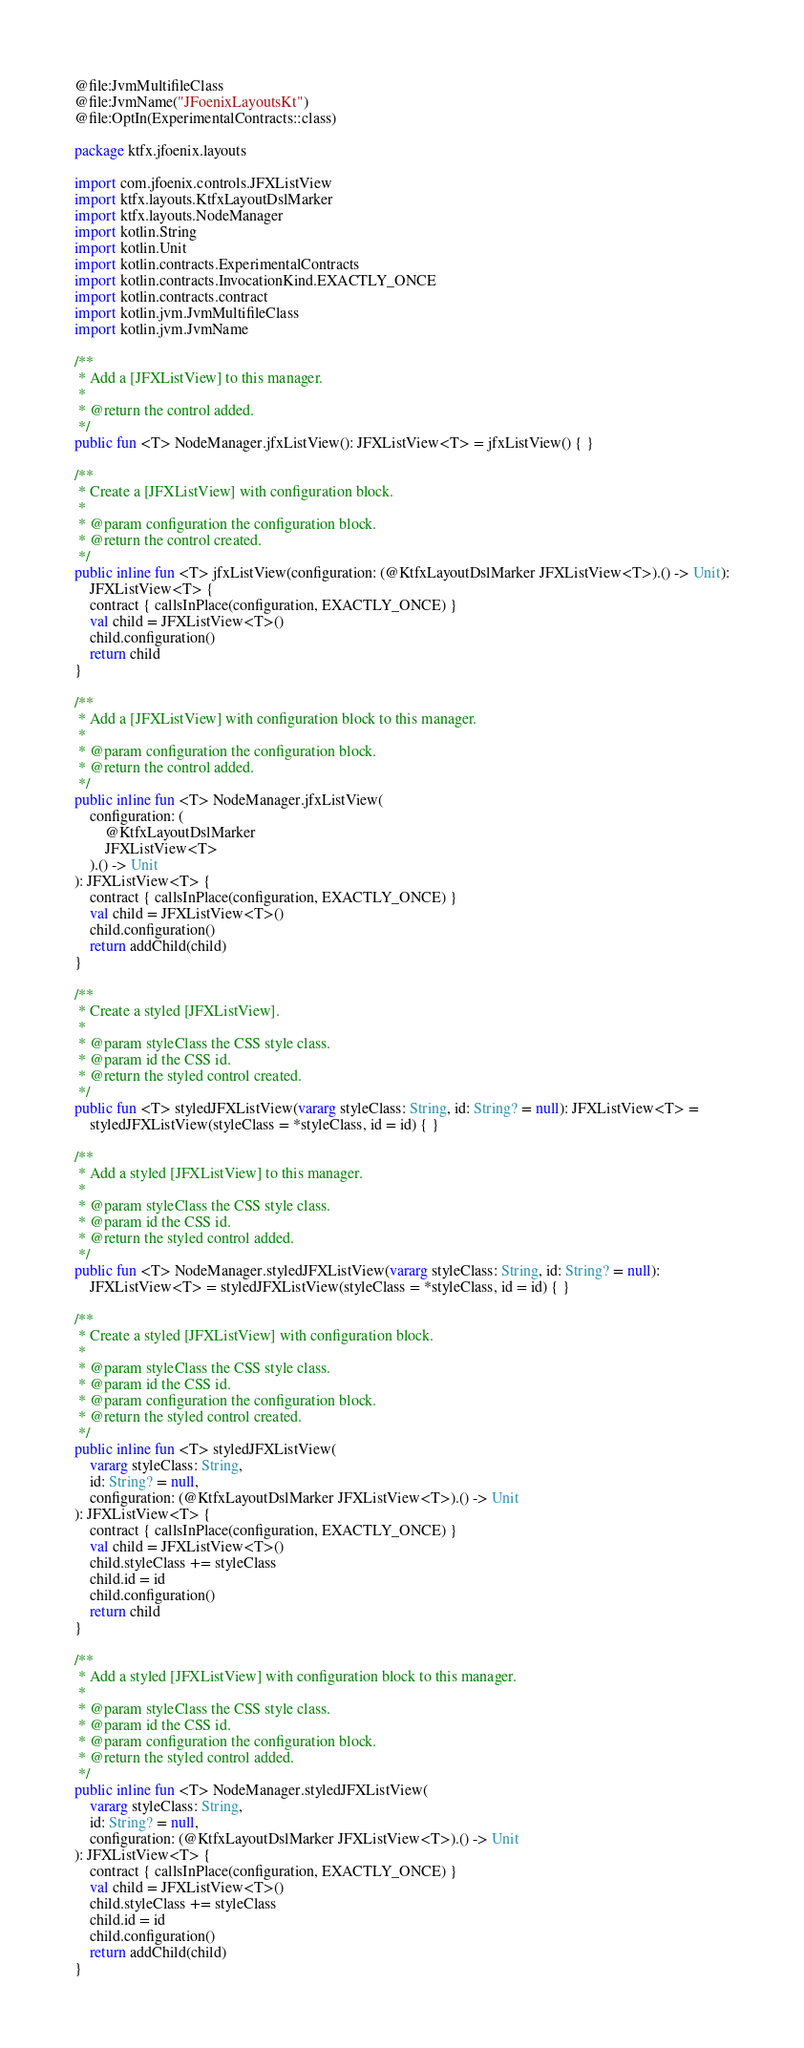Convert code to text. <code><loc_0><loc_0><loc_500><loc_500><_Kotlin_>@file:JvmMultifileClass
@file:JvmName("JFoenixLayoutsKt")
@file:OptIn(ExperimentalContracts::class)

package ktfx.jfoenix.layouts

import com.jfoenix.controls.JFXListView
import ktfx.layouts.KtfxLayoutDslMarker
import ktfx.layouts.NodeManager
import kotlin.String
import kotlin.Unit
import kotlin.contracts.ExperimentalContracts
import kotlin.contracts.InvocationKind.EXACTLY_ONCE
import kotlin.contracts.contract
import kotlin.jvm.JvmMultifileClass
import kotlin.jvm.JvmName

/**
 * Add a [JFXListView] to this manager.
 *
 * @return the control added.
 */
public fun <T> NodeManager.jfxListView(): JFXListView<T> = jfxListView() { }

/**
 * Create a [JFXListView] with configuration block.
 *
 * @param configuration the configuration block.
 * @return the control created.
 */
public inline fun <T> jfxListView(configuration: (@KtfxLayoutDslMarker JFXListView<T>).() -> Unit):
    JFXListView<T> {
    contract { callsInPlace(configuration, EXACTLY_ONCE) }
    val child = JFXListView<T>()
    child.configuration()
    return child
}

/**
 * Add a [JFXListView] with configuration block to this manager.
 *
 * @param configuration the configuration block.
 * @return the control added.
 */
public inline fun <T> NodeManager.jfxListView(
    configuration: (
        @KtfxLayoutDslMarker
        JFXListView<T>
    ).() -> Unit
): JFXListView<T> {
    contract { callsInPlace(configuration, EXACTLY_ONCE) }
    val child = JFXListView<T>()
    child.configuration()
    return addChild(child)
}

/**
 * Create a styled [JFXListView].
 *
 * @param styleClass the CSS style class.
 * @param id the CSS id.
 * @return the styled control created.
 */
public fun <T> styledJFXListView(vararg styleClass: String, id: String? = null): JFXListView<T> =
    styledJFXListView(styleClass = *styleClass, id = id) { }

/**
 * Add a styled [JFXListView] to this manager.
 *
 * @param styleClass the CSS style class.
 * @param id the CSS id.
 * @return the styled control added.
 */
public fun <T> NodeManager.styledJFXListView(vararg styleClass: String, id: String? = null):
    JFXListView<T> = styledJFXListView(styleClass = *styleClass, id = id) { }

/**
 * Create a styled [JFXListView] with configuration block.
 *
 * @param styleClass the CSS style class.
 * @param id the CSS id.
 * @param configuration the configuration block.
 * @return the styled control created.
 */
public inline fun <T> styledJFXListView(
    vararg styleClass: String,
    id: String? = null,
    configuration: (@KtfxLayoutDslMarker JFXListView<T>).() -> Unit
): JFXListView<T> {
    contract { callsInPlace(configuration, EXACTLY_ONCE) }
    val child = JFXListView<T>()
    child.styleClass += styleClass
    child.id = id
    child.configuration()
    return child
}

/**
 * Add a styled [JFXListView] with configuration block to this manager.
 *
 * @param styleClass the CSS style class.
 * @param id the CSS id.
 * @param configuration the configuration block.
 * @return the styled control added.
 */
public inline fun <T> NodeManager.styledJFXListView(
    vararg styleClass: String,
    id: String? = null,
    configuration: (@KtfxLayoutDslMarker JFXListView<T>).() -> Unit
): JFXListView<T> {
    contract { callsInPlace(configuration, EXACTLY_ONCE) }
    val child = JFXListView<T>()
    child.styleClass += styleClass
    child.id = id
    child.configuration()
    return addChild(child)
}
</code> 